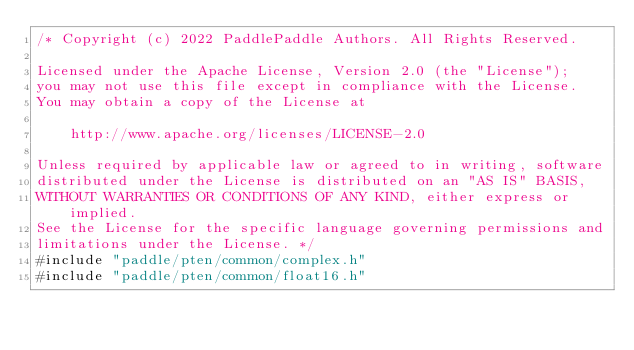<code> <loc_0><loc_0><loc_500><loc_500><_Cuda_>/* Copyright (c) 2022 PaddlePaddle Authors. All Rights Reserved.

Licensed under the Apache License, Version 2.0 (the "License");
you may not use this file except in compliance with the License.
You may obtain a copy of the License at

    http://www.apache.org/licenses/LICENSE-2.0

Unless required by applicable law or agreed to in writing, software
distributed under the License is distributed on an "AS IS" BASIS,
WITHOUT WARRANTIES OR CONDITIONS OF ANY KIND, either express or implied.
See the License for the specific language governing permissions and
limitations under the License. */
#include "paddle/pten/common/complex.h"
#include "paddle/pten/common/float16.h"</code> 